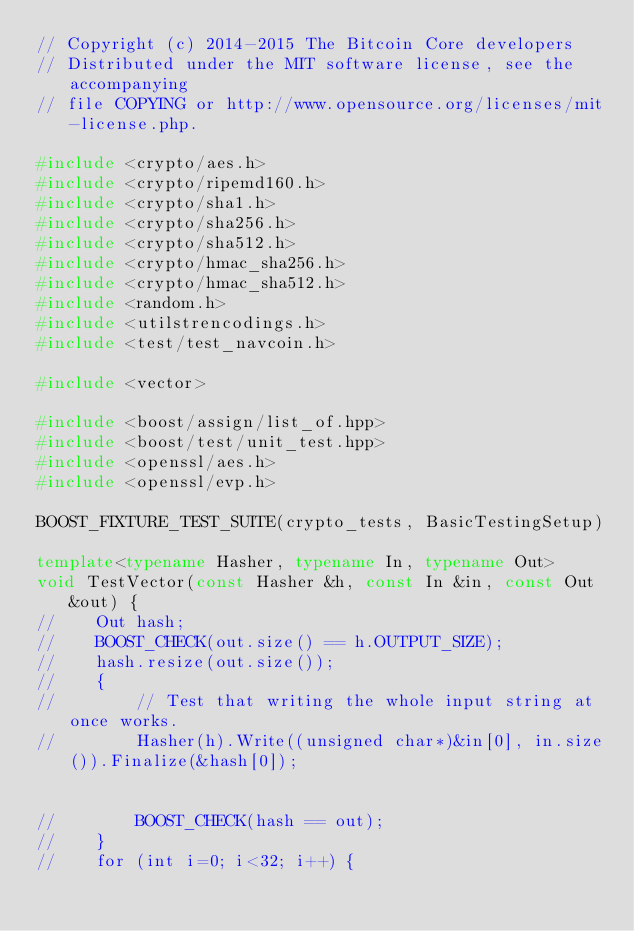Convert code to text. <code><loc_0><loc_0><loc_500><loc_500><_C++_>// Copyright (c) 2014-2015 The Bitcoin Core developers
// Distributed under the MIT software license, see the accompanying
// file COPYING or http://www.opensource.org/licenses/mit-license.php.

#include <crypto/aes.h>
#include <crypto/ripemd160.h>
#include <crypto/sha1.h>
#include <crypto/sha256.h>
#include <crypto/sha512.h>
#include <crypto/hmac_sha256.h>
#include <crypto/hmac_sha512.h>
#include <random.h>
#include <utilstrencodings.h>
#include <test/test_navcoin.h>

#include <vector>

#include <boost/assign/list_of.hpp>
#include <boost/test/unit_test.hpp>
#include <openssl/aes.h>
#include <openssl/evp.h>

BOOST_FIXTURE_TEST_SUITE(crypto_tests, BasicTestingSetup)

template<typename Hasher, typename In, typename Out>
void TestVector(const Hasher &h, const In &in, const Out &out) {
//    Out hash;
//    BOOST_CHECK(out.size() == h.OUTPUT_SIZE);
//    hash.resize(out.size());
//    {
//        // Test that writing the whole input string at once works.
//        Hasher(h).Write((unsigned char*)&in[0], in.size()).Finalize(&hash[0]);


//        BOOST_CHECK(hash == out);
//    }
//    for (int i=0; i<32; i++) {</code> 